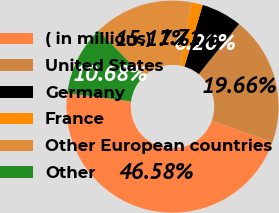<chart> <loc_0><loc_0><loc_500><loc_500><pie_chart><fcel>( in millions)<fcel>United States<fcel>Germany<fcel>France<fcel>Other European countries<fcel>Other<nl><fcel>46.58%<fcel>19.66%<fcel>6.2%<fcel>1.71%<fcel>15.17%<fcel>10.68%<nl></chart> 